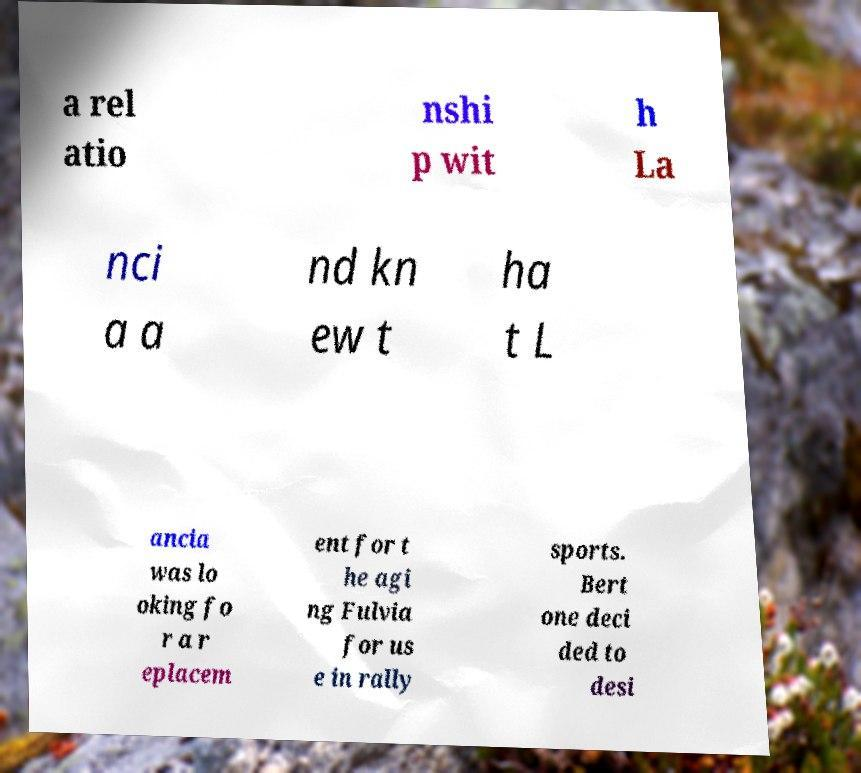Can you accurately transcribe the text from the provided image for me? a rel atio nshi p wit h La nci a a nd kn ew t ha t L ancia was lo oking fo r a r eplacem ent for t he agi ng Fulvia for us e in rally sports. Bert one deci ded to desi 